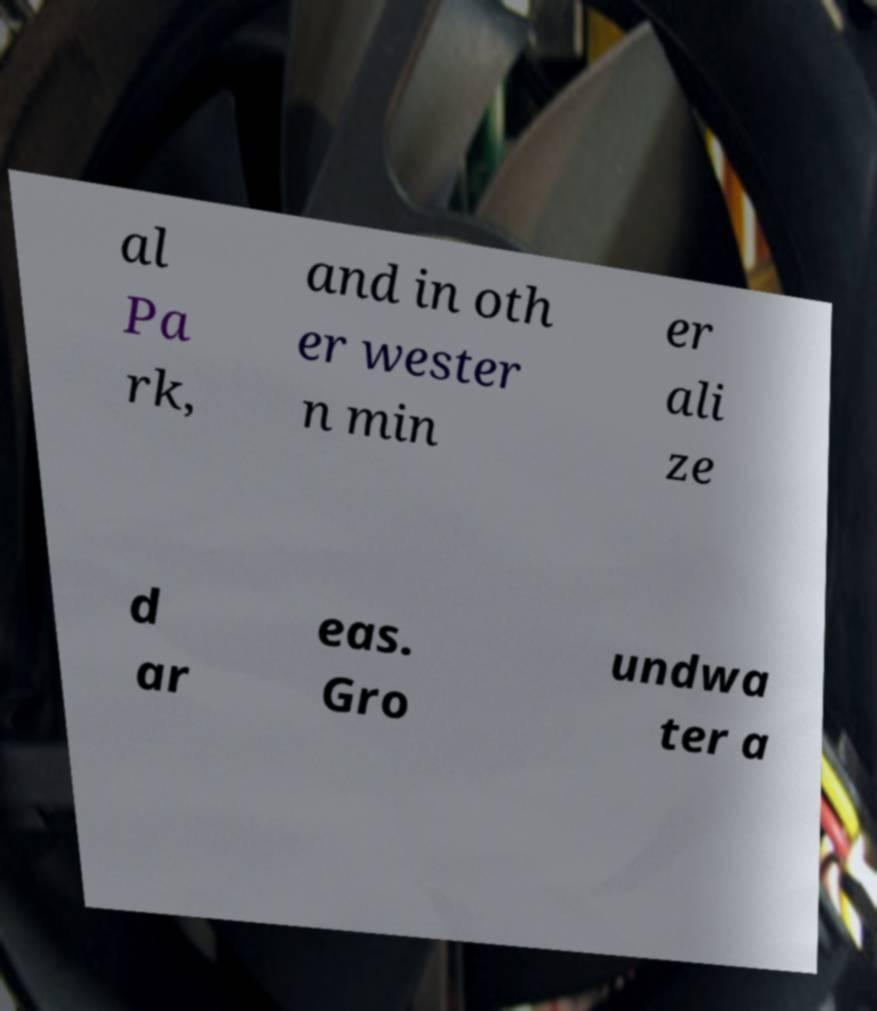Could you extract and type out the text from this image? al Pa rk, and in oth er wester n min er ali ze d ar eas. Gro undwa ter a 